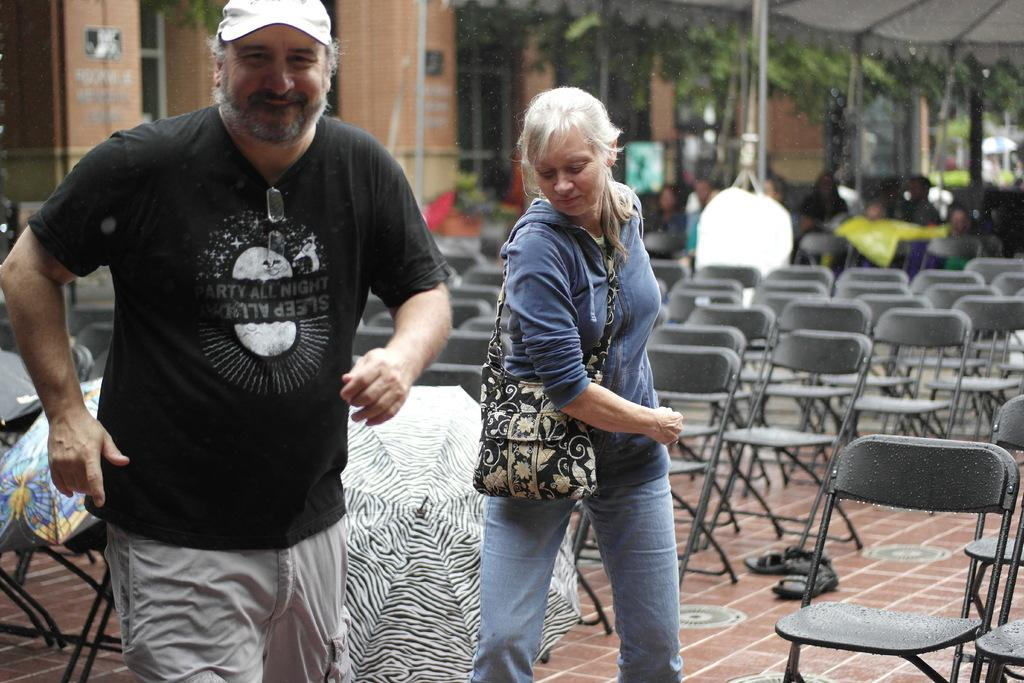How many people are present in the image? There is a man and a woman in the image. What objects are present in the image that might be used for protection from the elements? Umbrellas are present in the image. What type of furniture is visible in the image? Chairs are visible in the image. What personal item can be seen in the image? There is a bag in the image. What type of clothing is present in the image? Footwear is present in the image. What can be seen in the background of the image? There is a building and trees visible in the background of the image. What activity might the people in the background be engaged in? There are people sitting on chairs in the background of the image. How many cows are visible in the image? There are no cows present in the image. What type of fish can be seen swimming in the background of the image? There are no fish present in the image. 